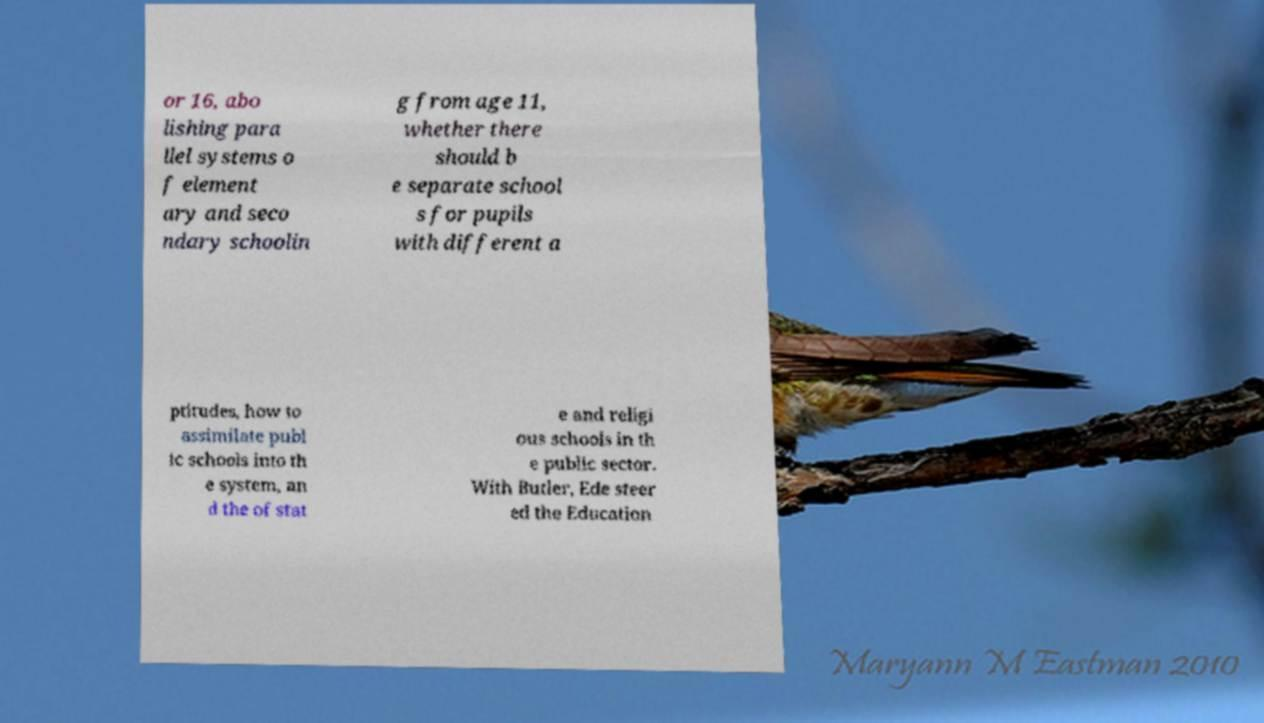Can you accurately transcribe the text from the provided image for me? or 16, abo lishing para llel systems o f element ary and seco ndary schoolin g from age 11, whether there should b e separate school s for pupils with different a ptitudes, how to assimilate publ ic schools into th e system, an d the of stat e and religi ous schools in th e public sector. With Butler, Ede steer ed the Education 